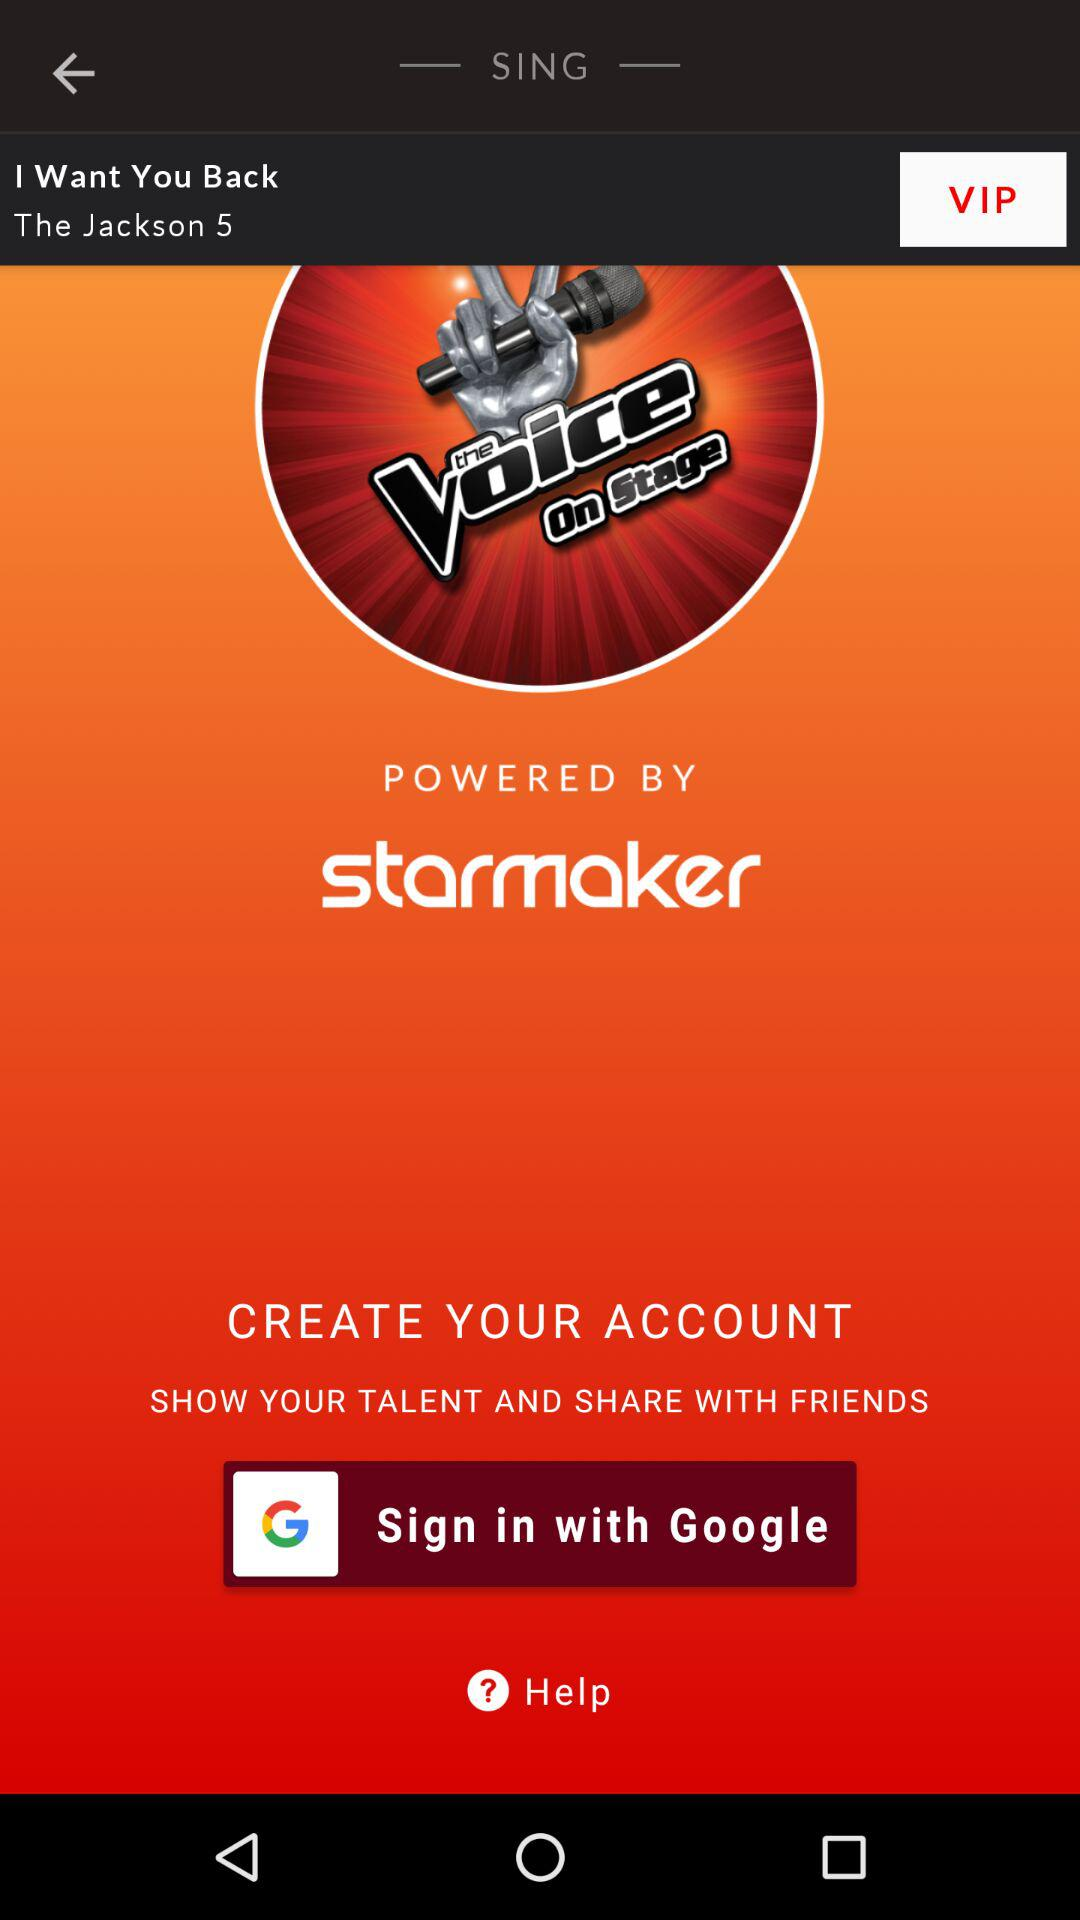Whom is it powered by? It is powered by "starmaker". 